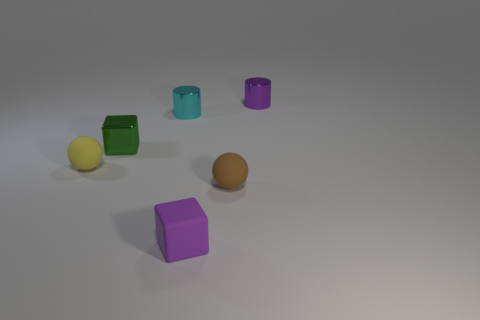Is the number of matte things that are in front of the tiny yellow sphere greater than the number of brown rubber balls?
Offer a terse response. Yes. What number of tiny things are in front of the matte sphere to the left of the cyan cylinder?
Keep it short and to the point. 2. Does the purple thing behind the tiny brown matte object have the same material as the purple object that is in front of the yellow rubber sphere?
Offer a very short reply. No. How many other objects are the same shape as the small brown thing?
Provide a short and direct response. 1. Are the tiny brown ball and the small purple object behind the purple block made of the same material?
Give a very brief answer. No. There is a green cube that is the same size as the purple shiny cylinder; what material is it?
Ensure brevity in your answer.  Metal. Are there any gray matte spheres that have the same size as the matte cube?
Make the answer very short. No. What is the shape of the purple metal thing that is the same size as the cyan shiny object?
Your answer should be very brief. Cylinder. How many other objects are the same color as the rubber cube?
Provide a succinct answer. 1. There is a thing that is on the left side of the cyan thing and in front of the small green block; what is its shape?
Keep it short and to the point. Sphere. 